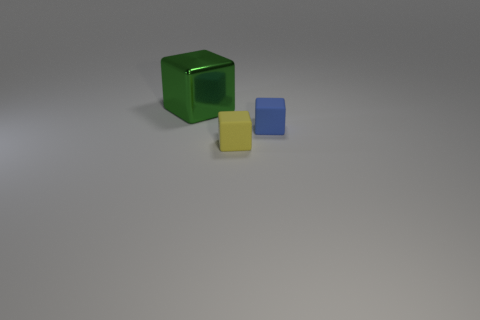Add 3 big green shiny cubes. How many objects exist? 6 Subtract all tiny yellow blocks. Subtract all green cubes. How many objects are left? 1 Add 2 small yellow cubes. How many small yellow cubes are left? 3 Add 3 big metal things. How many big metal things exist? 4 Subtract 0 purple balls. How many objects are left? 3 